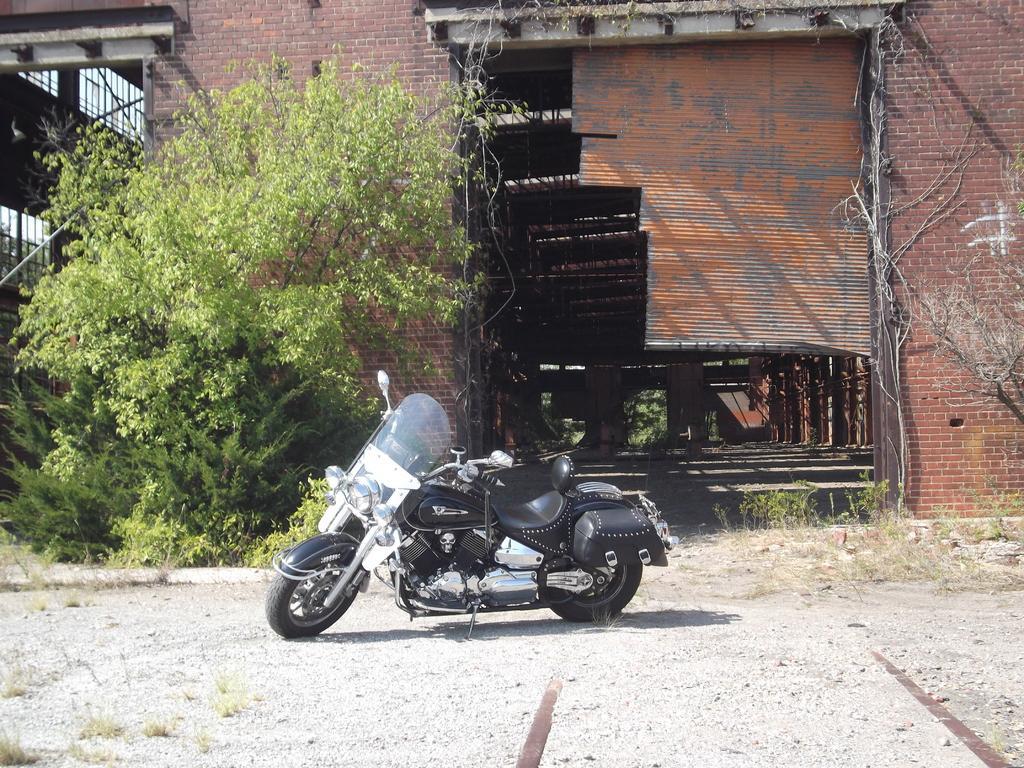How would you summarize this image in a sentence or two? In the center of the image there is a bike on the ground. In the background we can see trees, plants, building and shutters. 